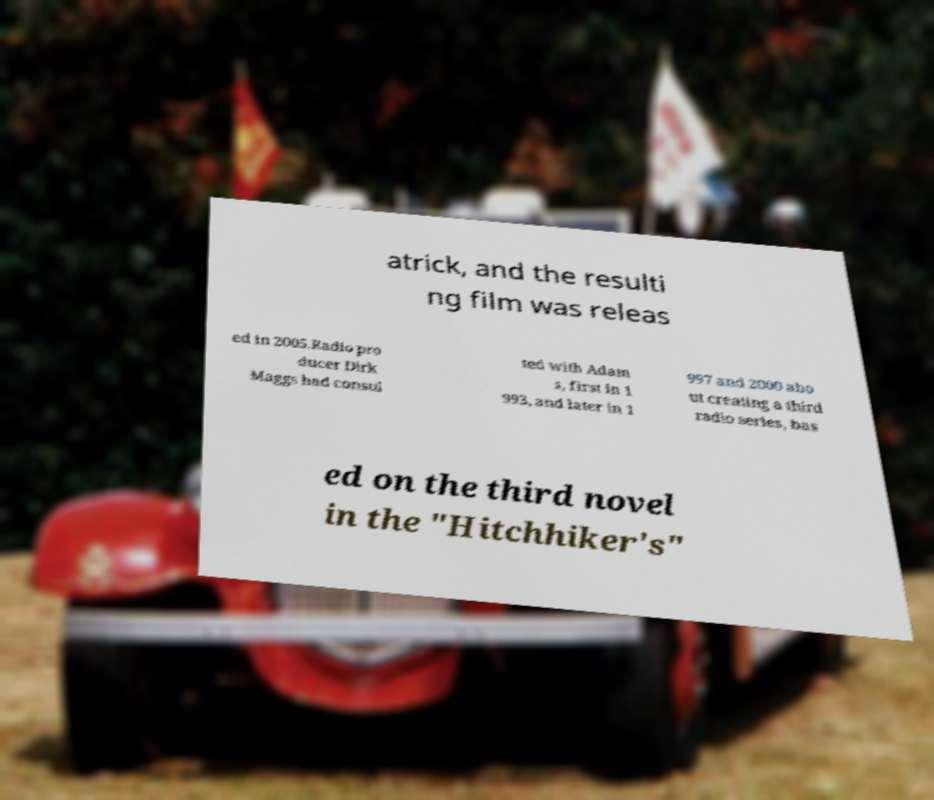Can you accurately transcribe the text from the provided image for me? atrick, and the resulti ng film was releas ed in 2005.Radio pro ducer Dirk Maggs had consul ted with Adam s, first in 1 993, and later in 1 997 and 2000 abo ut creating a third radio series, bas ed on the third novel in the "Hitchhiker's" 